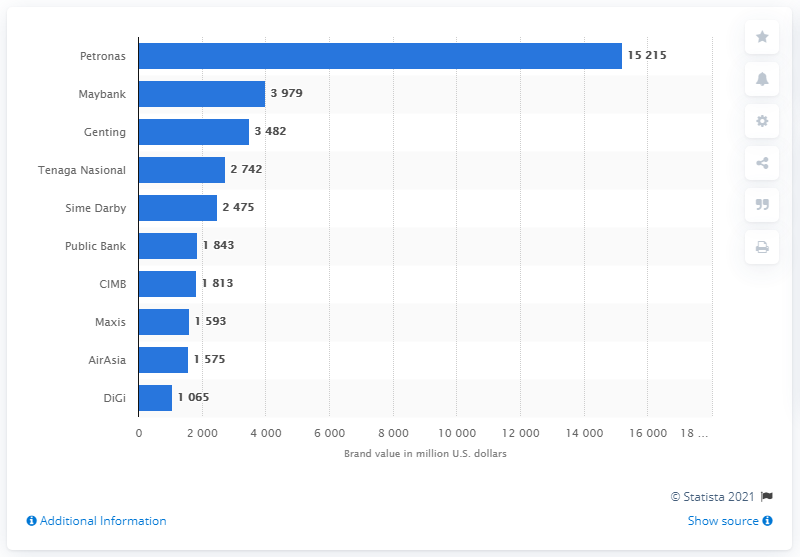Indicate a few pertinent items in this graphic. Maybank is the second most valuable Malaysian brand. Petronas' brand value in US dollars in 2020 was approximately 152,150. Maybank is the second most valuable Malaysian brand. 